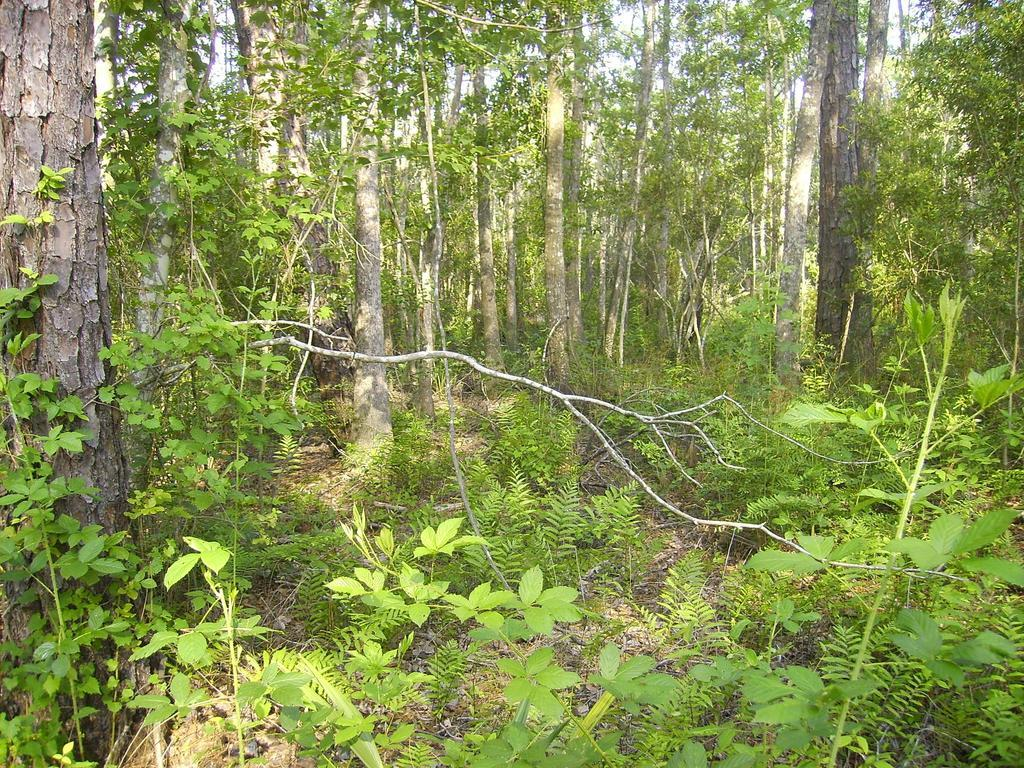What type of vegetation is visible in the image? There are trees and plants visible in the image. Can you describe the setting where the trees and plants are located? The setting is not specified, but the presence of trees and plants suggests a natural environment. What book is the person reading in the image? There is no person or book present in the image; it only features trees and plants. How many pipes can be seen in the image? There are no pipes visible in the image. What is the result of the addition problem shown on the board in the image? There is no board or addition problem present in the image. 